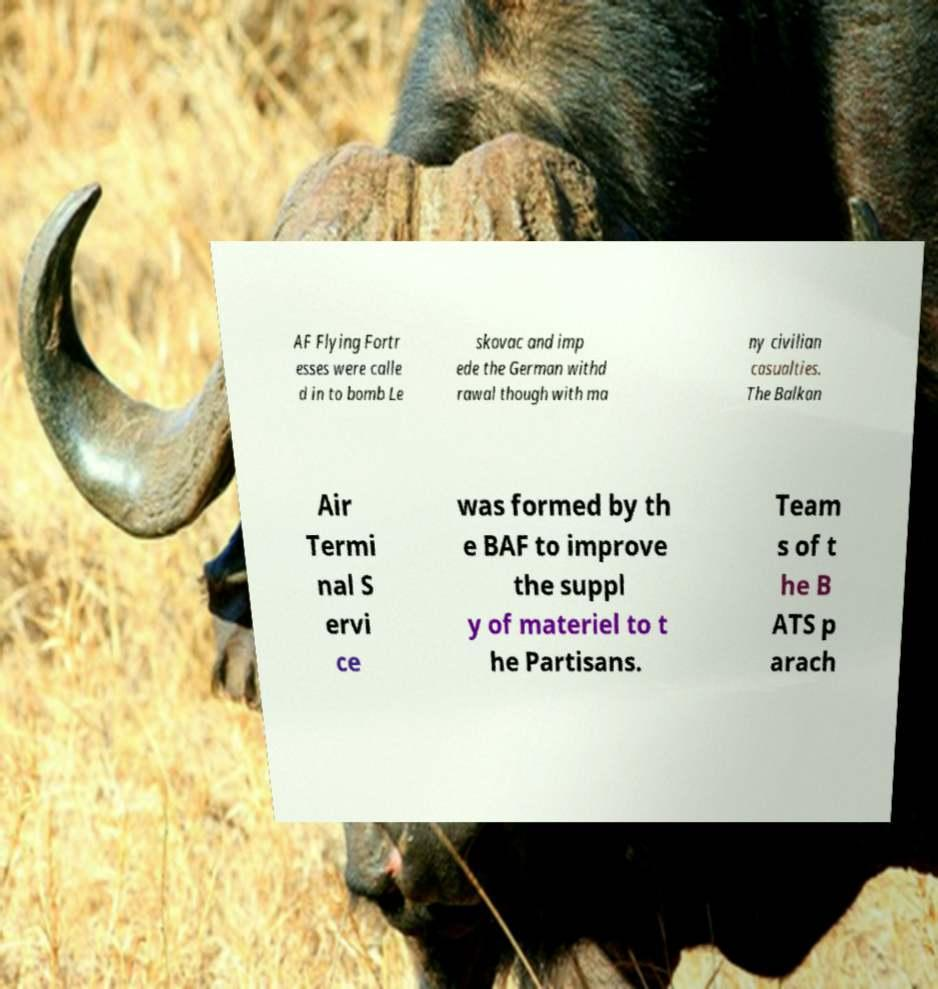There's text embedded in this image that I need extracted. Can you transcribe it verbatim? AF Flying Fortr esses were calle d in to bomb Le skovac and imp ede the German withd rawal though with ma ny civilian casualties. The Balkan Air Termi nal S ervi ce was formed by th e BAF to improve the suppl y of materiel to t he Partisans. Team s of t he B ATS p arach 